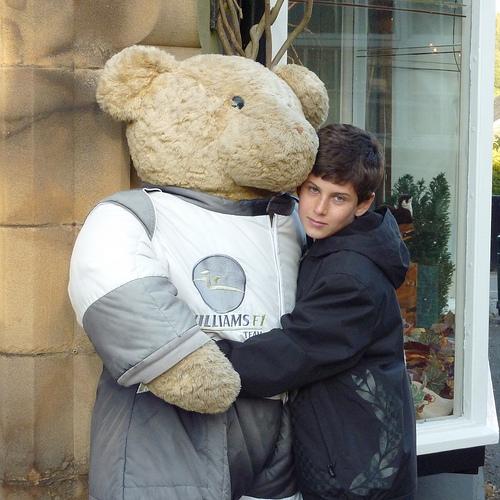Who has a white jacket?
Keep it brief. Bear. Is this a normal sized teddy bear?
Keep it brief. No. What color is the sweatshirt?
Answer briefly. Black. Is this kid sad?
Write a very short answer. No. Is the young man hugging the teddy bear for any specific reason?
Be succinct. No. What color is the teddy bear?
Answer briefly. Brown. 